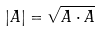Convert formula to latex. <formula><loc_0><loc_0><loc_500><loc_500>| A | = \sqrt { A \cdot A }</formula> 